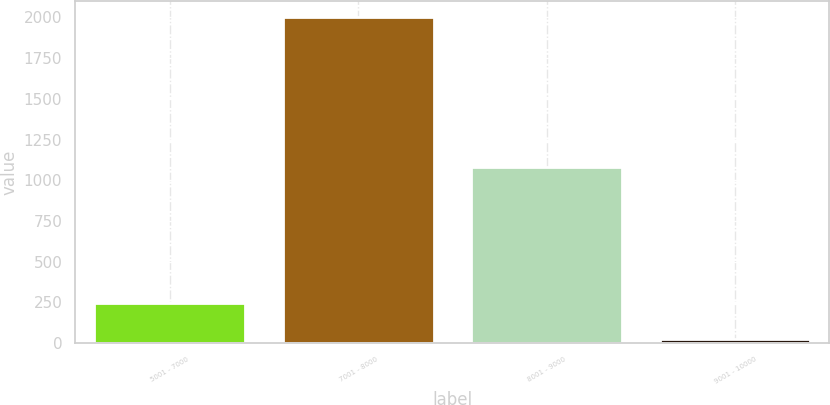Convert chart to OTSL. <chart><loc_0><loc_0><loc_500><loc_500><bar_chart><fcel>5001 - 7000<fcel>7001 - 8000<fcel>8001 - 9000<fcel>9001 - 10000<nl><fcel>246<fcel>2002<fcel>1081<fcel>27<nl></chart> 